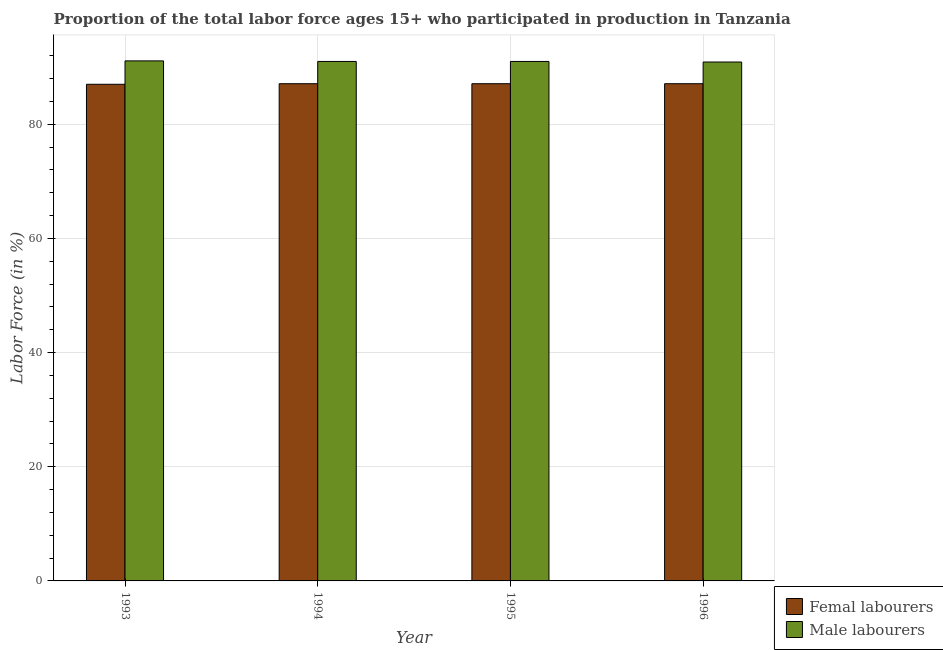How many different coloured bars are there?
Offer a very short reply. 2. Are the number of bars per tick equal to the number of legend labels?
Provide a short and direct response. Yes. Are the number of bars on each tick of the X-axis equal?
Offer a very short reply. Yes. How many bars are there on the 4th tick from the left?
Give a very brief answer. 2. What is the percentage of female labor force in 1996?
Keep it short and to the point. 87.1. Across all years, what is the maximum percentage of female labor force?
Offer a terse response. 87.1. Across all years, what is the minimum percentage of male labour force?
Offer a very short reply. 90.9. In which year was the percentage of male labour force maximum?
Your response must be concise. 1993. What is the total percentage of female labor force in the graph?
Provide a succinct answer. 348.3. What is the difference between the percentage of female labor force in 1993 and that in 1996?
Keep it short and to the point. -0.1. What is the difference between the percentage of female labor force in 1996 and the percentage of male labour force in 1993?
Keep it short and to the point. 0.1. What is the average percentage of male labour force per year?
Your response must be concise. 91. What is the ratio of the percentage of female labor force in 1993 to that in 1994?
Your answer should be very brief. 1. Is the percentage of male labour force in 1994 less than that in 1995?
Provide a succinct answer. No. What is the difference between the highest and the second highest percentage of male labour force?
Offer a terse response. 0.1. What is the difference between the highest and the lowest percentage of male labour force?
Your response must be concise. 0.2. In how many years, is the percentage of female labor force greater than the average percentage of female labor force taken over all years?
Provide a short and direct response. 3. Is the sum of the percentage of male labour force in 1994 and 1996 greater than the maximum percentage of female labor force across all years?
Make the answer very short. Yes. What does the 1st bar from the left in 1995 represents?
Your response must be concise. Femal labourers. What does the 2nd bar from the right in 1993 represents?
Make the answer very short. Femal labourers. How many bars are there?
Give a very brief answer. 8. Are all the bars in the graph horizontal?
Provide a succinct answer. No. Are the values on the major ticks of Y-axis written in scientific E-notation?
Keep it short and to the point. No. Does the graph contain grids?
Offer a terse response. Yes. Where does the legend appear in the graph?
Ensure brevity in your answer.  Bottom right. How many legend labels are there?
Keep it short and to the point. 2. How are the legend labels stacked?
Give a very brief answer. Vertical. What is the title of the graph?
Provide a succinct answer. Proportion of the total labor force ages 15+ who participated in production in Tanzania. What is the Labor Force (in %) of Male labourers in 1993?
Offer a terse response. 91.1. What is the Labor Force (in %) of Femal labourers in 1994?
Keep it short and to the point. 87.1. What is the Labor Force (in %) in Male labourers in 1994?
Provide a short and direct response. 91. What is the Labor Force (in %) of Femal labourers in 1995?
Make the answer very short. 87.1. What is the Labor Force (in %) of Male labourers in 1995?
Your answer should be compact. 91. What is the Labor Force (in %) of Femal labourers in 1996?
Make the answer very short. 87.1. What is the Labor Force (in %) of Male labourers in 1996?
Offer a very short reply. 90.9. Across all years, what is the maximum Labor Force (in %) of Femal labourers?
Offer a terse response. 87.1. Across all years, what is the maximum Labor Force (in %) in Male labourers?
Provide a succinct answer. 91.1. Across all years, what is the minimum Labor Force (in %) of Femal labourers?
Your answer should be very brief. 87. Across all years, what is the minimum Labor Force (in %) in Male labourers?
Give a very brief answer. 90.9. What is the total Labor Force (in %) in Femal labourers in the graph?
Your response must be concise. 348.3. What is the total Labor Force (in %) of Male labourers in the graph?
Give a very brief answer. 364. What is the difference between the Labor Force (in %) in Femal labourers in 1993 and that in 1994?
Your answer should be compact. -0.1. What is the difference between the Labor Force (in %) of Femal labourers in 1993 and that in 1995?
Your answer should be compact. -0.1. What is the difference between the Labor Force (in %) in Male labourers in 1993 and that in 1995?
Provide a succinct answer. 0.1. What is the difference between the Labor Force (in %) in Femal labourers in 1994 and that in 1995?
Make the answer very short. 0. What is the difference between the Labor Force (in %) of Male labourers in 1994 and that in 1996?
Give a very brief answer. 0.1. What is the difference between the Labor Force (in %) in Male labourers in 1995 and that in 1996?
Your answer should be very brief. 0.1. What is the difference between the Labor Force (in %) in Femal labourers in 1993 and the Labor Force (in %) in Male labourers in 1994?
Provide a succinct answer. -4. What is the difference between the Labor Force (in %) in Femal labourers in 1994 and the Labor Force (in %) in Male labourers in 1995?
Give a very brief answer. -3.9. What is the difference between the Labor Force (in %) in Femal labourers in 1995 and the Labor Force (in %) in Male labourers in 1996?
Keep it short and to the point. -3.8. What is the average Labor Force (in %) of Femal labourers per year?
Provide a succinct answer. 87.08. What is the average Labor Force (in %) of Male labourers per year?
Your response must be concise. 91. In the year 1993, what is the difference between the Labor Force (in %) of Femal labourers and Labor Force (in %) of Male labourers?
Your response must be concise. -4.1. In the year 1995, what is the difference between the Labor Force (in %) of Femal labourers and Labor Force (in %) of Male labourers?
Provide a short and direct response. -3.9. In the year 1996, what is the difference between the Labor Force (in %) of Femal labourers and Labor Force (in %) of Male labourers?
Your answer should be compact. -3.8. What is the ratio of the Labor Force (in %) of Male labourers in 1993 to that in 1994?
Provide a succinct answer. 1. What is the ratio of the Labor Force (in %) of Male labourers in 1993 to that in 1995?
Offer a very short reply. 1. What is the ratio of the Labor Force (in %) in Male labourers in 1994 to that in 1995?
Make the answer very short. 1. What is the ratio of the Labor Force (in %) of Male labourers in 1994 to that in 1996?
Provide a short and direct response. 1. What is the ratio of the Labor Force (in %) in Femal labourers in 1995 to that in 1996?
Ensure brevity in your answer.  1. What is the ratio of the Labor Force (in %) in Male labourers in 1995 to that in 1996?
Give a very brief answer. 1. What is the difference between the highest and the lowest Labor Force (in %) of Femal labourers?
Provide a short and direct response. 0.1. What is the difference between the highest and the lowest Labor Force (in %) in Male labourers?
Your answer should be very brief. 0.2. 